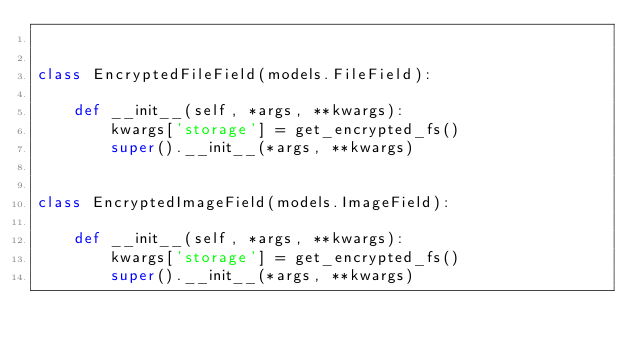Convert code to text. <code><loc_0><loc_0><loc_500><loc_500><_Python_>

class EncryptedFileField(models.FileField):

    def __init__(self, *args, **kwargs):
        kwargs['storage'] = get_encrypted_fs()
        super().__init__(*args, **kwargs)


class EncryptedImageField(models.ImageField):

    def __init__(self, *args, **kwargs):
        kwargs['storage'] = get_encrypted_fs()
        super().__init__(*args, **kwargs)
</code> 